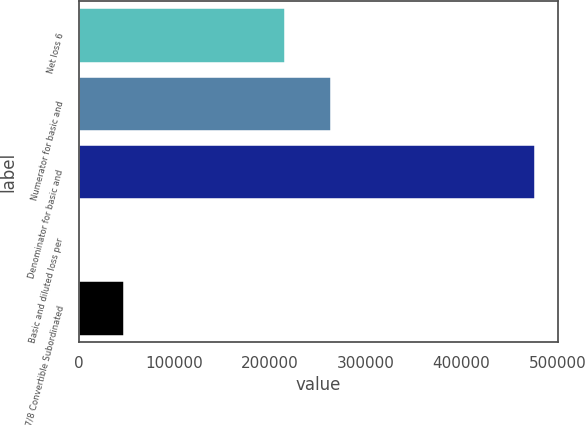Convert chart to OTSL. <chart><loc_0><loc_0><loc_500><loc_500><bar_chart><fcel>Net loss 6<fcel>Numerator for basic and<fcel>Denominator for basic and<fcel>Basic and diluted loss per<fcel>4 7/8 Convertible Subordinated<nl><fcel>215498<fcel>263215<fcel>477172<fcel>0.45<fcel>47717.6<nl></chart> 